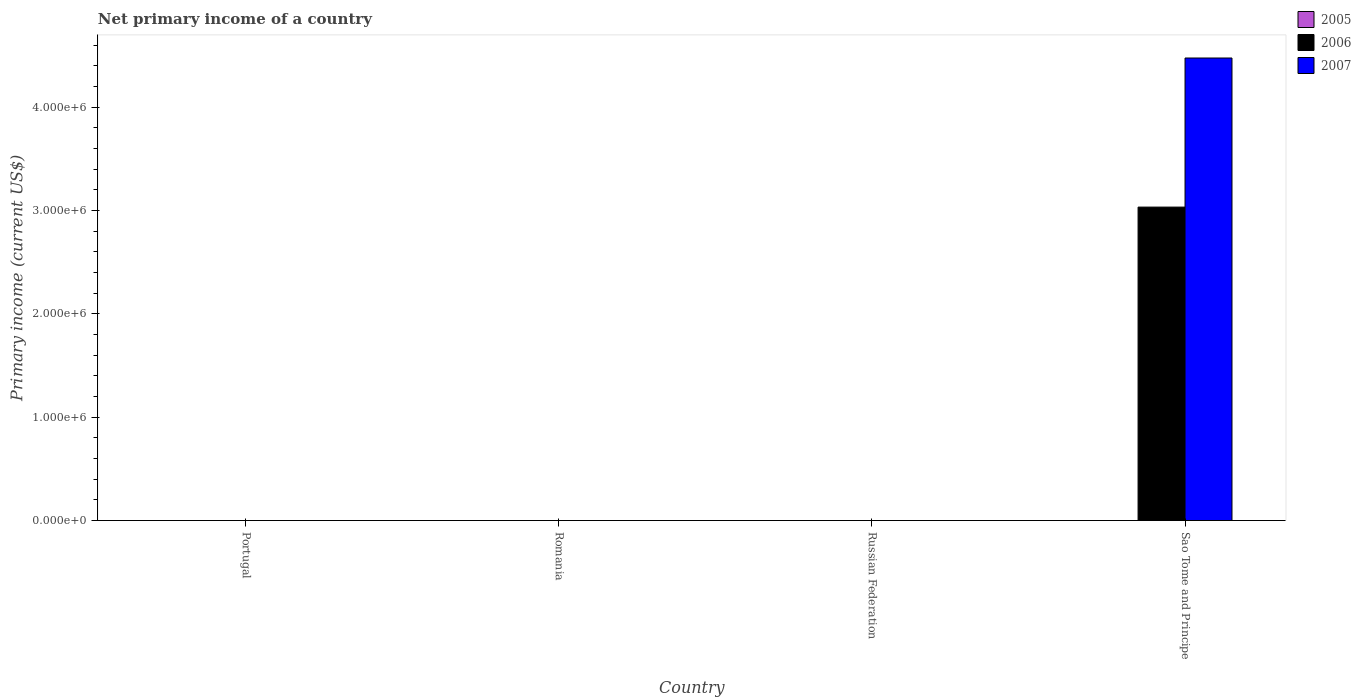How many different coloured bars are there?
Ensure brevity in your answer.  2. Are the number of bars on each tick of the X-axis equal?
Your answer should be compact. No. How many bars are there on the 3rd tick from the left?
Your answer should be very brief. 0. In how many cases, is the number of bars for a given country not equal to the number of legend labels?
Make the answer very short. 4. Across all countries, what is the maximum primary income in 2007?
Offer a very short reply. 4.47e+06. In which country was the primary income in 2007 maximum?
Give a very brief answer. Sao Tome and Principe. What is the total primary income in 2007 in the graph?
Your answer should be very brief. 4.47e+06. What is the average primary income in 2007 per country?
Your answer should be very brief. 1.12e+06. What is the difference between the primary income of/in 2007 and primary income of/in 2006 in Sao Tome and Principe?
Provide a short and direct response. 1.44e+06. In how many countries, is the primary income in 2006 greater than 1800000 US$?
Your answer should be compact. 1. What is the difference between the highest and the lowest primary income in 2006?
Give a very brief answer. 3.03e+06. In how many countries, is the primary income in 2007 greater than the average primary income in 2007 taken over all countries?
Give a very brief answer. 1. Is it the case that in every country, the sum of the primary income in 2006 and primary income in 2007 is greater than the primary income in 2005?
Ensure brevity in your answer.  No. Are all the bars in the graph horizontal?
Offer a very short reply. No. How many countries are there in the graph?
Provide a short and direct response. 4. Where does the legend appear in the graph?
Make the answer very short. Top right. How are the legend labels stacked?
Your response must be concise. Vertical. What is the title of the graph?
Give a very brief answer. Net primary income of a country. What is the label or title of the Y-axis?
Offer a very short reply. Primary income (current US$). What is the Primary income (current US$) of 2006 in Portugal?
Offer a very short reply. 0. What is the Primary income (current US$) of 2007 in Portugal?
Your response must be concise. 0. What is the Primary income (current US$) of 2006 in Romania?
Your answer should be compact. 0. What is the Primary income (current US$) in 2005 in Russian Federation?
Keep it short and to the point. 0. What is the Primary income (current US$) of 2006 in Russian Federation?
Your answer should be compact. 0. What is the Primary income (current US$) of 2007 in Russian Federation?
Offer a very short reply. 0. What is the Primary income (current US$) in 2006 in Sao Tome and Principe?
Your answer should be compact. 3.03e+06. What is the Primary income (current US$) of 2007 in Sao Tome and Principe?
Ensure brevity in your answer.  4.47e+06. Across all countries, what is the maximum Primary income (current US$) in 2006?
Your answer should be compact. 3.03e+06. Across all countries, what is the maximum Primary income (current US$) of 2007?
Ensure brevity in your answer.  4.47e+06. Across all countries, what is the minimum Primary income (current US$) of 2006?
Offer a very short reply. 0. Across all countries, what is the minimum Primary income (current US$) of 2007?
Your answer should be very brief. 0. What is the total Primary income (current US$) in 2006 in the graph?
Your response must be concise. 3.03e+06. What is the total Primary income (current US$) of 2007 in the graph?
Give a very brief answer. 4.47e+06. What is the average Primary income (current US$) in 2005 per country?
Ensure brevity in your answer.  0. What is the average Primary income (current US$) of 2006 per country?
Your answer should be very brief. 7.58e+05. What is the average Primary income (current US$) of 2007 per country?
Offer a terse response. 1.12e+06. What is the difference between the Primary income (current US$) in 2006 and Primary income (current US$) in 2007 in Sao Tome and Principe?
Make the answer very short. -1.44e+06. What is the difference between the highest and the lowest Primary income (current US$) of 2006?
Ensure brevity in your answer.  3.03e+06. What is the difference between the highest and the lowest Primary income (current US$) in 2007?
Make the answer very short. 4.47e+06. 